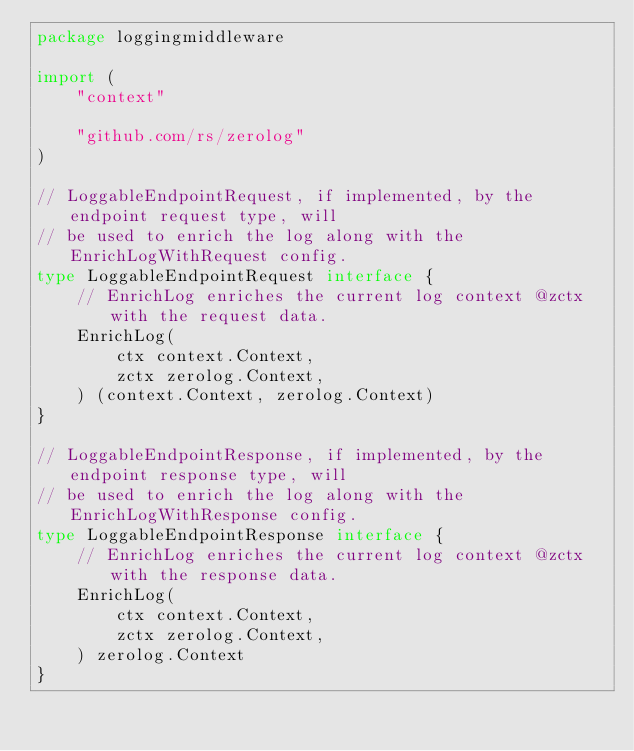<code> <loc_0><loc_0><loc_500><loc_500><_Go_>package loggingmiddleware

import (
	"context"

	"github.com/rs/zerolog"
)

// LoggableEndpointRequest, if implemented, by the endpoint request type, will
// be used to enrich the log along with the EnrichLogWithRequest config.
type LoggableEndpointRequest interface {
	// EnrichLog enriches the current log context @zctx with the request data.
	EnrichLog(
		ctx context.Context,
		zctx zerolog.Context,
	) (context.Context, zerolog.Context)
}

// LoggableEndpointResponse, if implemented, by the endpoint response type, will
// be used to enrich the log along with the EnrichLogWithResponse config.
type LoggableEndpointResponse interface {
	// EnrichLog enriches the current log context @zctx with the response data.
	EnrichLog(
		ctx context.Context,
		zctx zerolog.Context,
	) zerolog.Context
}
</code> 